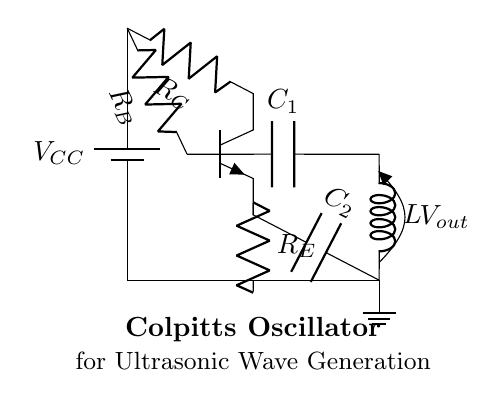What is the type of transistor used in the circuit? The circuit diagram shows an NP transistor symbol, indicating that an NPN transistor is used. The letter 'N' in NPN stands for the type of material used in the transistor junctions.
Answer: NPN What is the function of the capacitors in the circuit? The capacitors in the Colpitts oscillator function to determine the frequency of oscillation. In this configuration, they form part of the feedback network that influences the phase shift required for oscillation.
Answer: Frequency determination What components are involved in feedback for the oscillator? The feedback in a Colpitts oscillator is primarily provided by the capacitors C1 and C2, and the inductor L. This combination is crucial for establishing the oscillation condition.
Answer: Capacitors C1, C2, and inductor L What is the role of the resistor labeled R_E? The resistor R_E typically serves as the emitter resistor in transistor circuits, providing stability to the circuit and affecting biasing conditions as it helps setting the DC operating point for the transistor.
Answer: Emitter stabilization What kind of waveforms does a Colpitts oscillator generate? The Colpitts oscillator produces sinusoidal waveforms typically at ultrasonic frequencies due to its specific design that allows for resonant oscillation in the given frequency range.
Answer: Sinusoidal waveforms How does the voltage labeling indicate output? The output voltage V_out is labeled across the inductor and capacitor combination, which signifies the point from where the oscillating signal can be taken. The specific labeling indicates the point of interest for output retrieval.
Answer: Output voltage point 